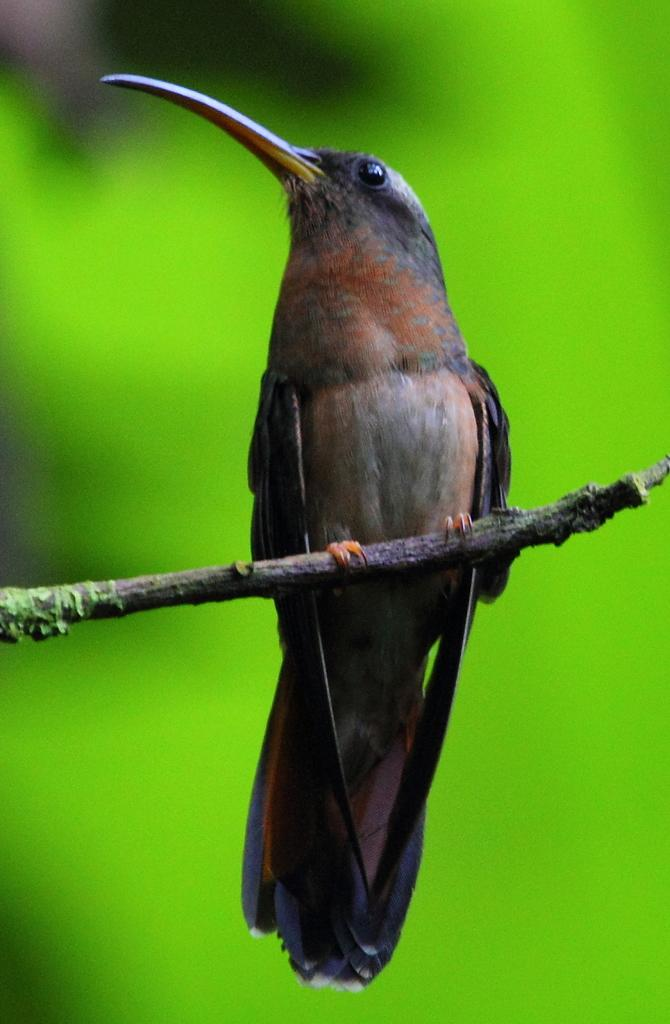What type of animal is in the image? There is a bird in the image. Where is the bird located? The bird is on a stem. What color is the background of the image? The background of the image is green. Can you see the bird smiling in the image? There is no indication of the bird's facial expression in the image, so it cannot be determined if the bird is smiling. 